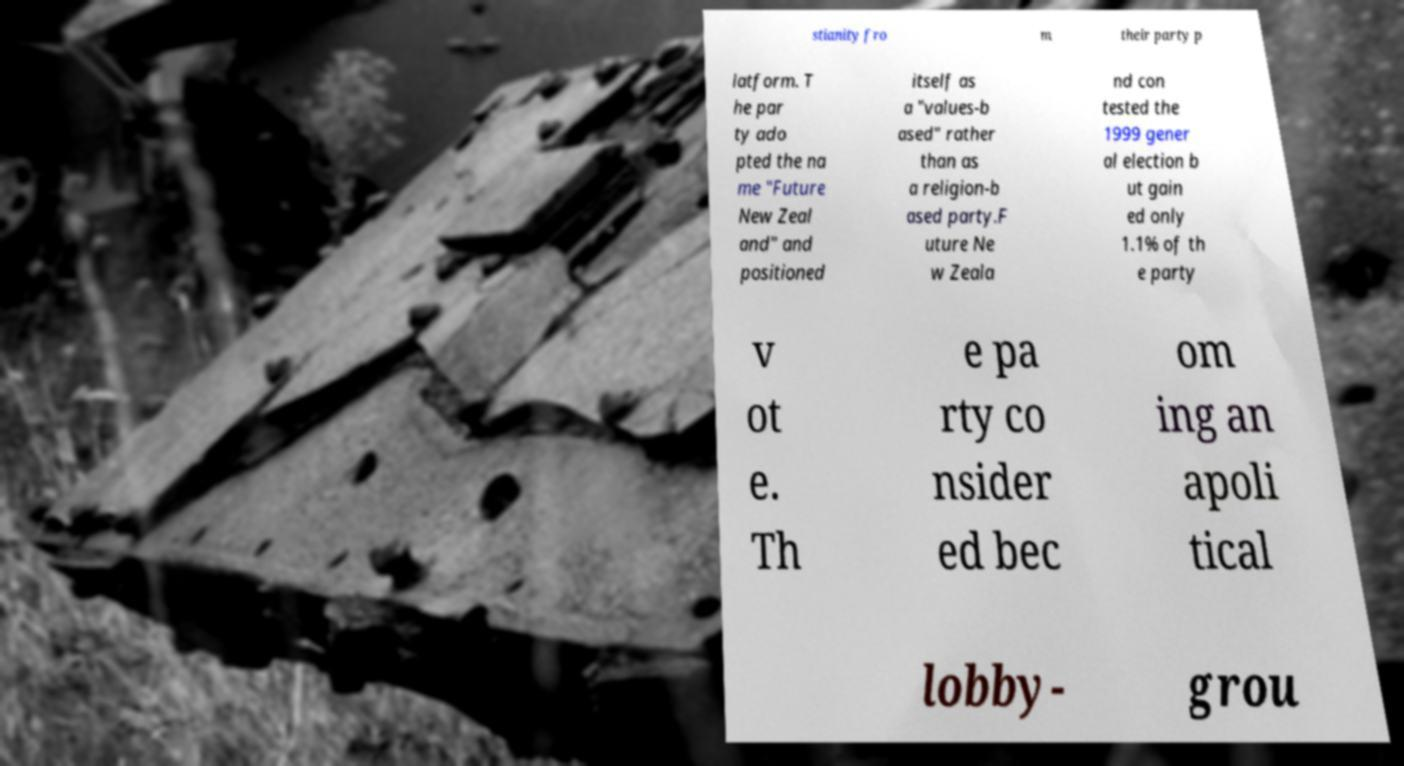I need the written content from this picture converted into text. Can you do that? stianity fro m their party p latform. T he par ty ado pted the na me "Future New Zeal and" and positioned itself as a "values-b ased" rather than as a religion-b ased party.F uture Ne w Zeala nd con tested the 1999 gener al election b ut gain ed only 1.1% of th e party v ot e. Th e pa rty co nsider ed bec om ing an apoli tical lobby- grou 